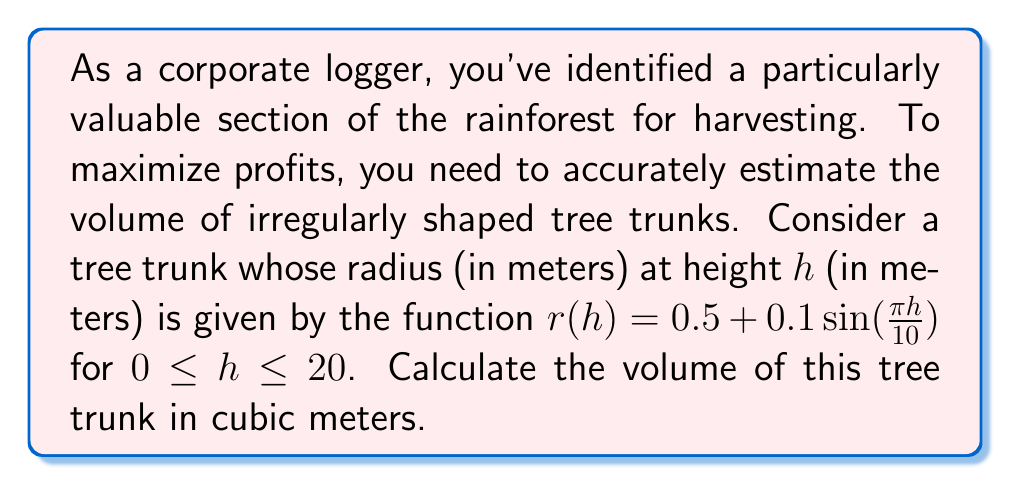Show me your answer to this math problem. To calculate the volume of an irregularly shaped tree trunk, we can use the method of cylindrical shells. The volume is given by the integral:

$$V = \int_0^H \pi r(h)^2 dh$$

Where $H$ is the height of the tree trunk and $r(h)$ is the radius as a function of height.

For this problem:
$r(h) = 0.5 + 0.1\sin(\frac{\pi h}{10})$
$H = 20$ meters

Let's substitute these into our integral:

$$V = \int_0^{20} \pi (0.5 + 0.1\sin(\frac{\pi h}{10}))^2 dh$$

Expanding the squared term:

$$V = \pi \int_0^{20} (0.25 + 0.1\sin(\frac{\pi h}{10}) + 0.01\sin^2(\frac{\pi h}{10})) dh$$

Now, let's integrate each term separately:

1. $\int_0^{20} 0.25 dh = 0.25h \big|_0^{20} = 5$

2. $\int_0^{20} 0.1\sin(\frac{\pi h}{10}) dh = -\frac{1}{\pi} \cos(\frac{\pi h}{10}) \big|_0^{20} = -\frac{1}{\pi}(\cos(2\pi) - 1) = 0$

3. For the $\sin^2$ term, we can use the identity $\sin^2(x) = \frac{1 - \cos(2x)}{2}$:

   $\int_0^{20} 0.01\sin^2(\frac{\pi h}{10}) dh = \int_0^{20} 0.005(1 - \cos(\frac{\pi h}{5})) dh$
   
   $= 0.005h - 0.005 \cdot \frac{5}{\pi} \sin(\frac{\pi h}{5}) \big|_0^{20}$
   
   $= 0.1 - 0.005 \cdot \frac{5}{\pi} (\sin(4\pi) - \sin(0)) = 0.1$

Adding these results and multiplying by $\pi$:

$$V = \pi(5 + 0 + 0.1) = 5.1\pi$$
Answer: The volume of the tree trunk is $5.1\pi \approx 16.02$ cubic meters. 